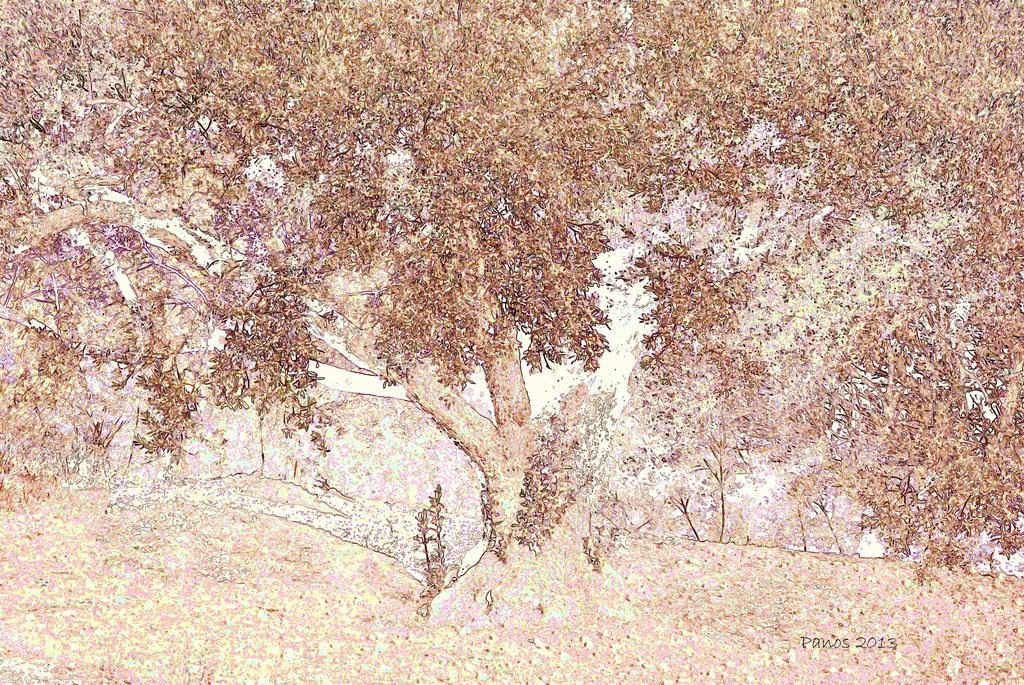What type of image is being described? The image appears to be an edited photo. What natural elements can be seen in the image? There are trees, grass, and plants in the image. How much money is being exchanged between the girls in the image? There are no girls present in the image, and no money exchange is taking place. 